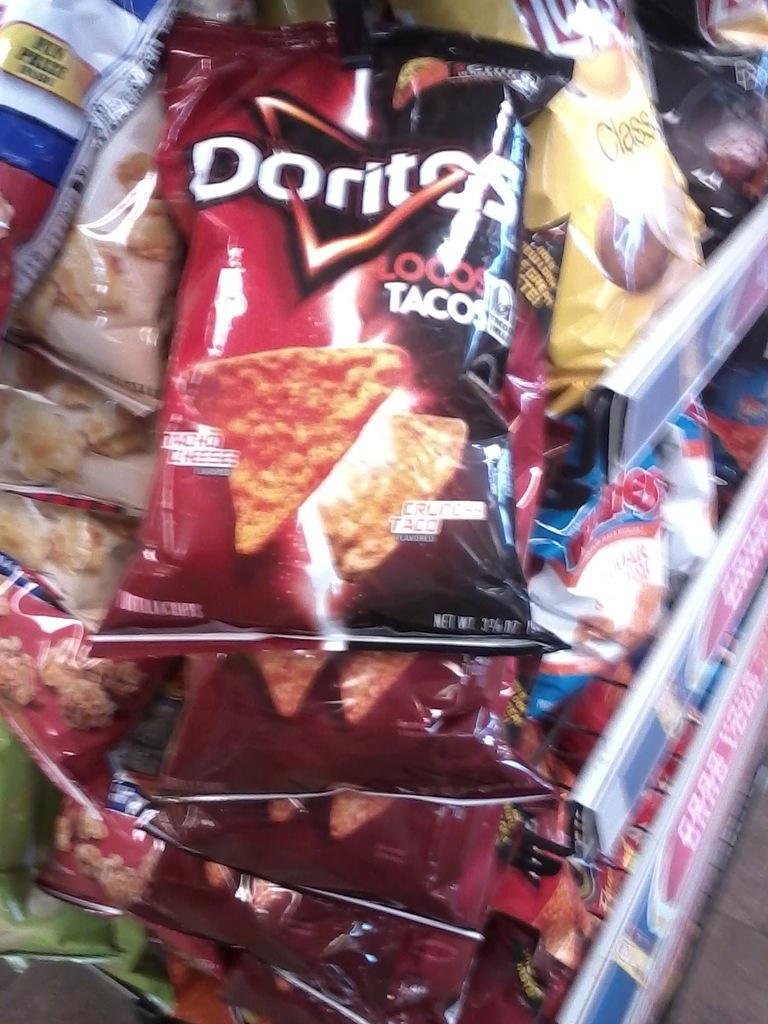<image>
Provide a brief description of the given image. Packages of Potato Chips on a store shelf, brands like Lays, Doritos, and Ruffles. 